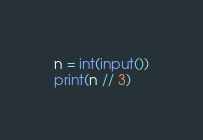Convert code to text. <code><loc_0><loc_0><loc_500><loc_500><_Python_>n = int(input())
print(n // 3)</code> 